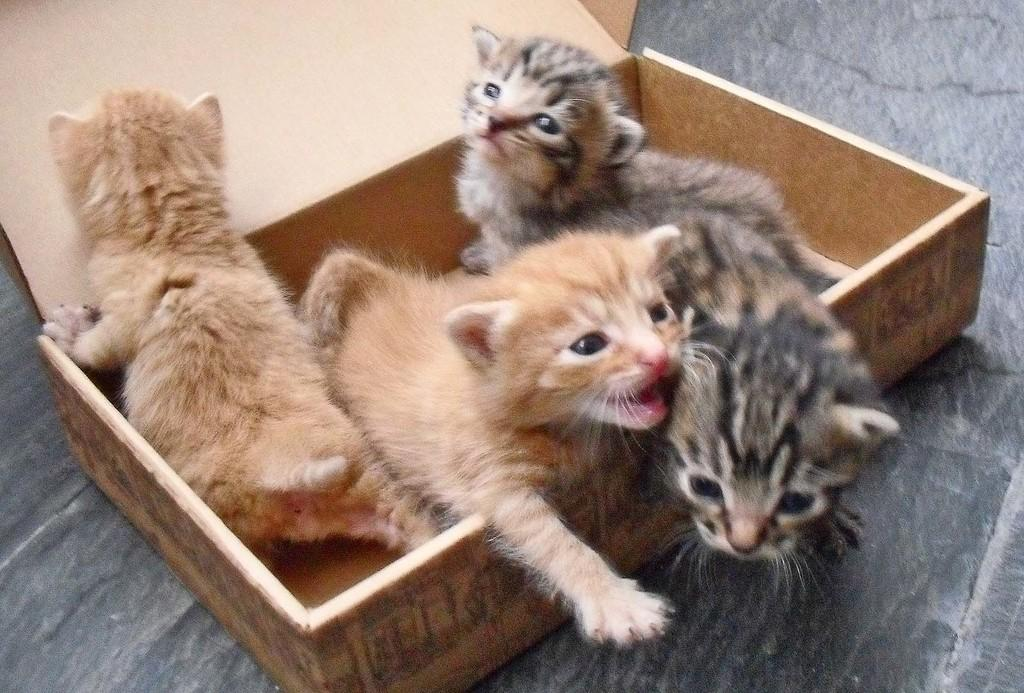How many kittens are present in the image? There are four kittens in the image. Where are the kittens located? The kittens are placed in a wooden box. What type of material is used to make the box? The box is made of wood. What can be seen at the top of the image? There are wooden planks or a box visible at the top of the image. What is visible at the bottom of the image? The floor is visible at the bottom of the image. What type of slope can be seen in the image? There is no slope present in the image. 